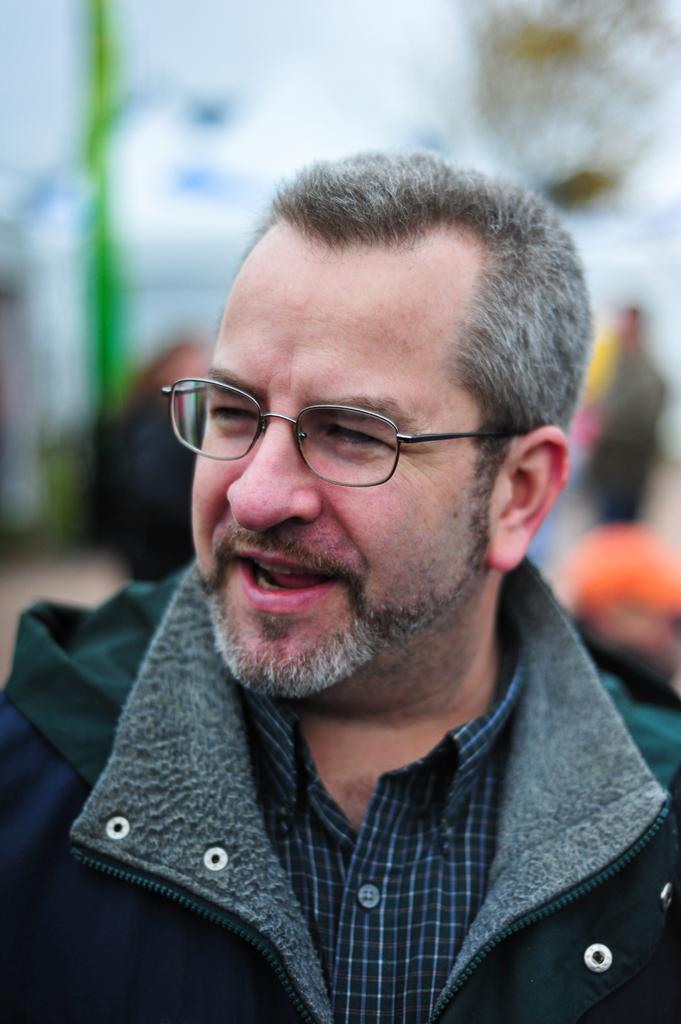How would you summarize this image in a sentence or two? In this image we can see a person There are few people behind a person. There is a blur background in the image. 